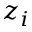<formula> <loc_0><loc_0><loc_500><loc_500>z _ { i }</formula> 